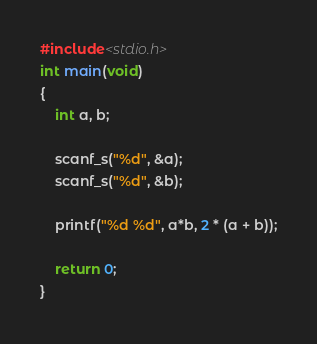<code> <loc_0><loc_0><loc_500><loc_500><_C_>#include<stdio.h>
int main(void)
{
	int a, b;

	scanf_s("%d", &a);
	scanf_s("%d", &b);

	printf("%d %d", a*b, 2 * (a + b));

	return 0;
}
</code> 